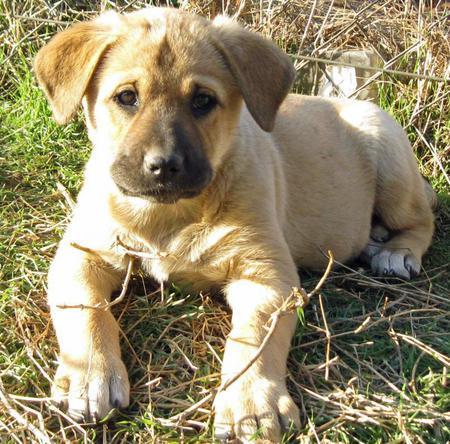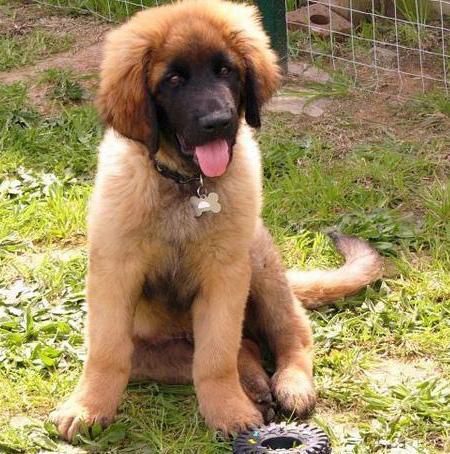The first image is the image on the left, the second image is the image on the right. For the images shown, is this caption "One image shows a dog walking toward the camera." true? Answer yes or no. No. The first image is the image on the left, the second image is the image on the right. Evaluate the accuracy of this statement regarding the images: "A puppy is laying in the grass.". Is it true? Answer yes or no. Yes. 